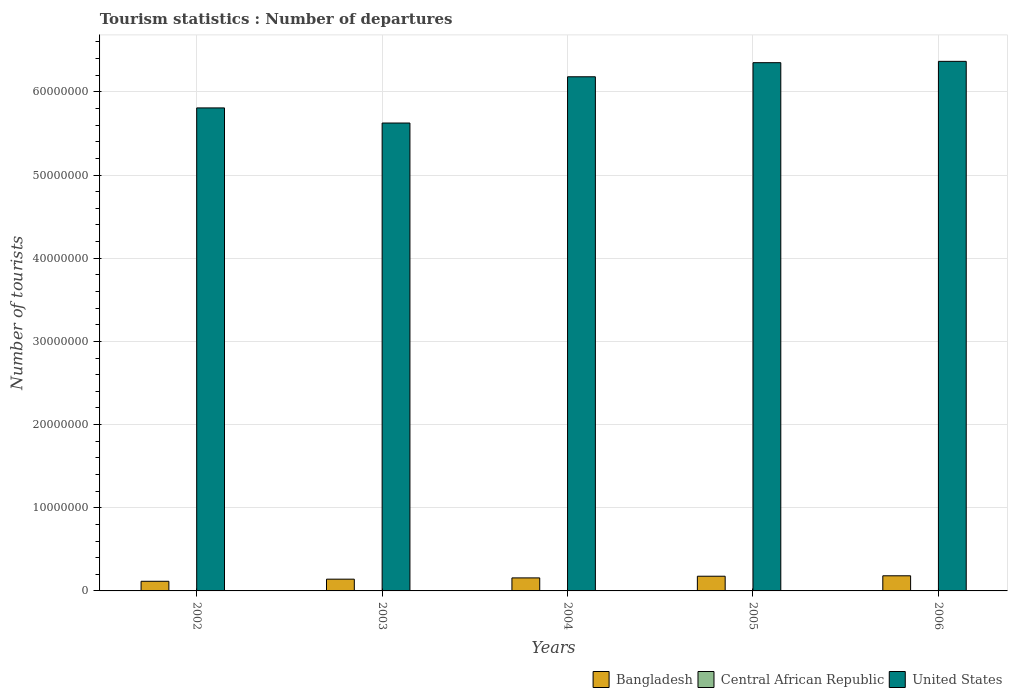How many groups of bars are there?
Provide a short and direct response. 5. Are the number of bars on each tick of the X-axis equal?
Keep it short and to the point. Yes. How many bars are there on the 3rd tick from the right?
Offer a very short reply. 3. What is the label of the 4th group of bars from the left?
Ensure brevity in your answer.  2005. In how many cases, is the number of bars for a given year not equal to the number of legend labels?
Your answer should be compact. 0. What is the number of tourist departures in Bangladesh in 2004?
Make the answer very short. 1.56e+06. Across all years, what is the maximum number of tourist departures in Bangladesh?
Make the answer very short. 1.82e+06. Across all years, what is the minimum number of tourist departures in Bangladesh?
Provide a succinct answer. 1.16e+06. In which year was the number of tourist departures in Bangladesh maximum?
Keep it short and to the point. 2006. In which year was the number of tourist departures in United States minimum?
Ensure brevity in your answer.  2003. What is the total number of tourist departures in Central African Republic in the graph?
Ensure brevity in your answer.  3.70e+04. What is the difference between the number of tourist departures in Central African Republic in 2002 and that in 2003?
Make the answer very short. -1000. What is the difference between the number of tourist departures in United States in 2005 and the number of tourist departures in Central African Republic in 2002?
Offer a very short reply. 6.35e+07. What is the average number of tourist departures in Central African Republic per year?
Make the answer very short. 7400. In the year 2002, what is the difference between the number of tourist departures in Bangladesh and number of tourist departures in United States?
Make the answer very short. -5.69e+07. What is the ratio of the number of tourist departures in Central African Republic in 2002 to that in 2004?
Provide a short and direct response. 0.71. Is the difference between the number of tourist departures in Bangladesh in 2003 and 2005 greater than the difference between the number of tourist departures in United States in 2003 and 2005?
Your answer should be compact. Yes. What is the difference between the highest and the second highest number of tourist departures in Central African Republic?
Offer a terse response. 3000. What is the difference between the highest and the lowest number of tourist departures in Bangladesh?
Make the answer very short. 6.61e+05. What does the 3rd bar from the left in 2004 represents?
Make the answer very short. United States. Is it the case that in every year, the sum of the number of tourist departures in Bangladesh and number of tourist departures in United States is greater than the number of tourist departures in Central African Republic?
Make the answer very short. Yes. How many bars are there?
Your answer should be very brief. 15. Are all the bars in the graph horizontal?
Your response must be concise. No. What is the difference between two consecutive major ticks on the Y-axis?
Give a very brief answer. 1.00e+07. Are the values on the major ticks of Y-axis written in scientific E-notation?
Provide a succinct answer. No. Does the graph contain any zero values?
Your response must be concise. No. Does the graph contain grids?
Your answer should be compact. Yes. What is the title of the graph?
Make the answer very short. Tourism statistics : Number of departures. What is the label or title of the X-axis?
Your answer should be very brief. Years. What is the label or title of the Y-axis?
Offer a terse response. Number of tourists. What is the Number of tourists in Bangladesh in 2002?
Your answer should be compact. 1.16e+06. What is the Number of tourists in United States in 2002?
Give a very brief answer. 5.81e+07. What is the Number of tourists of Bangladesh in 2003?
Keep it short and to the point. 1.41e+06. What is the Number of tourists of Central African Republic in 2003?
Your answer should be very brief. 6000. What is the Number of tourists of United States in 2003?
Make the answer very short. 5.62e+07. What is the Number of tourists in Bangladesh in 2004?
Keep it short and to the point. 1.56e+06. What is the Number of tourists of Central African Republic in 2004?
Your answer should be very brief. 7000. What is the Number of tourists in United States in 2004?
Your answer should be very brief. 6.18e+07. What is the Number of tourists in Bangladesh in 2005?
Make the answer very short. 1.77e+06. What is the Number of tourists of Central African Republic in 2005?
Make the answer very short. 8000. What is the Number of tourists of United States in 2005?
Provide a succinct answer. 6.35e+07. What is the Number of tourists in Bangladesh in 2006?
Your response must be concise. 1.82e+06. What is the Number of tourists in Central African Republic in 2006?
Make the answer very short. 1.10e+04. What is the Number of tourists in United States in 2006?
Offer a very short reply. 6.37e+07. Across all years, what is the maximum Number of tourists in Bangladesh?
Make the answer very short. 1.82e+06. Across all years, what is the maximum Number of tourists of Central African Republic?
Offer a very short reply. 1.10e+04. Across all years, what is the maximum Number of tourists in United States?
Provide a succinct answer. 6.37e+07. Across all years, what is the minimum Number of tourists in Bangladesh?
Offer a very short reply. 1.16e+06. Across all years, what is the minimum Number of tourists of Central African Republic?
Keep it short and to the point. 5000. Across all years, what is the minimum Number of tourists in United States?
Provide a succinct answer. 5.62e+07. What is the total Number of tourists in Bangladesh in the graph?
Keep it short and to the point. 7.72e+06. What is the total Number of tourists of Central African Republic in the graph?
Your answer should be compact. 3.70e+04. What is the total Number of tourists of United States in the graph?
Provide a succinct answer. 3.03e+08. What is the difference between the Number of tourists of Bangladesh in 2002 and that in 2003?
Provide a short and direct response. -2.56e+05. What is the difference between the Number of tourists of Central African Republic in 2002 and that in 2003?
Make the answer very short. -1000. What is the difference between the Number of tourists of United States in 2002 and that in 2003?
Your response must be concise. 1.82e+06. What is the difference between the Number of tourists in Bangladesh in 2002 and that in 2004?
Ensure brevity in your answer.  -4.07e+05. What is the difference between the Number of tourists in Central African Republic in 2002 and that in 2004?
Ensure brevity in your answer.  -2000. What is the difference between the Number of tourists of United States in 2002 and that in 2004?
Provide a succinct answer. -3.74e+06. What is the difference between the Number of tourists in Bangladesh in 2002 and that in 2005?
Make the answer very short. -6.09e+05. What is the difference between the Number of tourists in Central African Republic in 2002 and that in 2005?
Your answer should be compact. -3000. What is the difference between the Number of tourists in United States in 2002 and that in 2005?
Your response must be concise. -5.44e+06. What is the difference between the Number of tourists in Bangladesh in 2002 and that in 2006?
Your answer should be compact. -6.61e+05. What is the difference between the Number of tourists in Central African Republic in 2002 and that in 2006?
Your response must be concise. -6000. What is the difference between the Number of tourists in United States in 2002 and that in 2006?
Provide a succinct answer. -5.60e+06. What is the difference between the Number of tourists in Bangladesh in 2003 and that in 2004?
Your response must be concise. -1.51e+05. What is the difference between the Number of tourists of Central African Republic in 2003 and that in 2004?
Your answer should be compact. -1000. What is the difference between the Number of tourists of United States in 2003 and that in 2004?
Provide a short and direct response. -5.56e+06. What is the difference between the Number of tourists in Bangladesh in 2003 and that in 2005?
Your answer should be very brief. -3.53e+05. What is the difference between the Number of tourists in Central African Republic in 2003 and that in 2005?
Your answer should be compact. -2000. What is the difference between the Number of tourists of United States in 2003 and that in 2005?
Your answer should be compact. -7.25e+06. What is the difference between the Number of tourists in Bangladesh in 2003 and that in 2006?
Your response must be concise. -4.05e+05. What is the difference between the Number of tourists of Central African Republic in 2003 and that in 2006?
Make the answer very short. -5000. What is the difference between the Number of tourists in United States in 2003 and that in 2006?
Offer a terse response. -7.41e+06. What is the difference between the Number of tourists of Bangladesh in 2004 and that in 2005?
Ensure brevity in your answer.  -2.02e+05. What is the difference between the Number of tourists of Central African Republic in 2004 and that in 2005?
Ensure brevity in your answer.  -1000. What is the difference between the Number of tourists in United States in 2004 and that in 2005?
Provide a succinct answer. -1.69e+06. What is the difference between the Number of tourists in Bangladesh in 2004 and that in 2006?
Ensure brevity in your answer.  -2.54e+05. What is the difference between the Number of tourists in Central African Republic in 2004 and that in 2006?
Make the answer very short. -4000. What is the difference between the Number of tourists of United States in 2004 and that in 2006?
Give a very brief answer. -1.85e+06. What is the difference between the Number of tourists of Bangladesh in 2005 and that in 2006?
Ensure brevity in your answer.  -5.20e+04. What is the difference between the Number of tourists of Central African Republic in 2005 and that in 2006?
Your answer should be very brief. -3000. What is the difference between the Number of tourists in Bangladesh in 2002 and the Number of tourists in Central African Republic in 2003?
Give a very brief answer. 1.15e+06. What is the difference between the Number of tourists in Bangladesh in 2002 and the Number of tourists in United States in 2003?
Make the answer very short. -5.51e+07. What is the difference between the Number of tourists in Central African Republic in 2002 and the Number of tourists in United States in 2003?
Offer a terse response. -5.62e+07. What is the difference between the Number of tourists in Bangladesh in 2002 and the Number of tourists in Central African Republic in 2004?
Give a very brief answer. 1.15e+06. What is the difference between the Number of tourists in Bangladesh in 2002 and the Number of tourists in United States in 2004?
Provide a succinct answer. -6.07e+07. What is the difference between the Number of tourists in Central African Republic in 2002 and the Number of tourists in United States in 2004?
Give a very brief answer. -6.18e+07. What is the difference between the Number of tourists in Bangladesh in 2002 and the Number of tourists in Central African Republic in 2005?
Keep it short and to the point. 1.15e+06. What is the difference between the Number of tourists in Bangladesh in 2002 and the Number of tourists in United States in 2005?
Your answer should be compact. -6.23e+07. What is the difference between the Number of tourists of Central African Republic in 2002 and the Number of tourists of United States in 2005?
Make the answer very short. -6.35e+07. What is the difference between the Number of tourists of Bangladesh in 2002 and the Number of tourists of Central African Republic in 2006?
Your answer should be compact. 1.15e+06. What is the difference between the Number of tourists of Bangladesh in 2002 and the Number of tourists of United States in 2006?
Provide a short and direct response. -6.25e+07. What is the difference between the Number of tourists of Central African Republic in 2002 and the Number of tourists of United States in 2006?
Your answer should be very brief. -6.37e+07. What is the difference between the Number of tourists in Bangladesh in 2003 and the Number of tourists in Central African Republic in 2004?
Offer a very short reply. 1.41e+06. What is the difference between the Number of tourists of Bangladesh in 2003 and the Number of tourists of United States in 2004?
Provide a succinct answer. -6.04e+07. What is the difference between the Number of tourists of Central African Republic in 2003 and the Number of tourists of United States in 2004?
Your response must be concise. -6.18e+07. What is the difference between the Number of tourists in Bangladesh in 2003 and the Number of tourists in Central African Republic in 2005?
Provide a short and direct response. 1.41e+06. What is the difference between the Number of tourists in Bangladesh in 2003 and the Number of tourists in United States in 2005?
Make the answer very short. -6.21e+07. What is the difference between the Number of tourists of Central African Republic in 2003 and the Number of tourists of United States in 2005?
Offer a very short reply. -6.35e+07. What is the difference between the Number of tourists in Bangladesh in 2003 and the Number of tourists in Central African Republic in 2006?
Your answer should be compact. 1.40e+06. What is the difference between the Number of tourists of Bangladesh in 2003 and the Number of tourists of United States in 2006?
Your response must be concise. -6.22e+07. What is the difference between the Number of tourists of Central African Republic in 2003 and the Number of tourists of United States in 2006?
Offer a terse response. -6.37e+07. What is the difference between the Number of tourists in Bangladesh in 2004 and the Number of tourists in Central African Republic in 2005?
Provide a short and direct response. 1.56e+06. What is the difference between the Number of tourists in Bangladesh in 2004 and the Number of tourists in United States in 2005?
Your answer should be very brief. -6.19e+07. What is the difference between the Number of tourists of Central African Republic in 2004 and the Number of tourists of United States in 2005?
Provide a short and direct response. -6.35e+07. What is the difference between the Number of tourists in Bangladesh in 2004 and the Number of tourists in Central African Republic in 2006?
Make the answer very short. 1.55e+06. What is the difference between the Number of tourists of Bangladesh in 2004 and the Number of tourists of United States in 2006?
Provide a short and direct response. -6.21e+07. What is the difference between the Number of tourists in Central African Republic in 2004 and the Number of tourists in United States in 2006?
Make the answer very short. -6.37e+07. What is the difference between the Number of tourists of Bangladesh in 2005 and the Number of tourists of Central African Republic in 2006?
Provide a succinct answer. 1.76e+06. What is the difference between the Number of tourists in Bangladesh in 2005 and the Number of tourists in United States in 2006?
Provide a succinct answer. -6.19e+07. What is the difference between the Number of tourists of Central African Republic in 2005 and the Number of tourists of United States in 2006?
Give a very brief answer. -6.37e+07. What is the average Number of tourists in Bangladesh per year?
Keep it short and to the point. 1.54e+06. What is the average Number of tourists in Central African Republic per year?
Provide a succinct answer. 7400. What is the average Number of tourists in United States per year?
Offer a terse response. 6.07e+07. In the year 2002, what is the difference between the Number of tourists of Bangladesh and Number of tourists of Central African Republic?
Your answer should be compact. 1.15e+06. In the year 2002, what is the difference between the Number of tourists in Bangladesh and Number of tourists in United States?
Make the answer very short. -5.69e+07. In the year 2002, what is the difference between the Number of tourists in Central African Republic and Number of tourists in United States?
Give a very brief answer. -5.81e+07. In the year 2003, what is the difference between the Number of tourists in Bangladesh and Number of tourists in Central African Republic?
Give a very brief answer. 1.41e+06. In the year 2003, what is the difference between the Number of tourists in Bangladesh and Number of tourists in United States?
Offer a very short reply. -5.48e+07. In the year 2003, what is the difference between the Number of tourists of Central African Republic and Number of tourists of United States?
Keep it short and to the point. -5.62e+07. In the year 2004, what is the difference between the Number of tourists in Bangladesh and Number of tourists in Central African Republic?
Your answer should be compact. 1.56e+06. In the year 2004, what is the difference between the Number of tourists in Bangladesh and Number of tourists in United States?
Provide a short and direct response. -6.02e+07. In the year 2004, what is the difference between the Number of tourists in Central African Republic and Number of tourists in United States?
Keep it short and to the point. -6.18e+07. In the year 2005, what is the difference between the Number of tourists in Bangladesh and Number of tourists in Central African Republic?
Your response must be concise. 1.76e+06. In the year 2005, what is the difference between the Number of tourists of Bangladesh and Number of tourists of United States?
Keep it short and to the point. -6.17e+07. In the year 2005, what is the difference between the Number of tourists of Central African Republic and Number of tourists of United States?
Provide a succinct answer. -6.35e+07. In the year 2006, what is the difference between the Number of tourists in Bangladesh and Number of tourists in Central African Republic?
Provide a short and direct response. 1.81e+06. In the year 2006, what is the difference between the Number of tourists in Bangladesh and Number of tourists in United States?
Your answer should be very brief. -6.18e+07. In the year 2006, what is the difference between the Number of tourists in Central African Republic and Number of tourists in United States?
Provide a succinct answer. -6.37e+07. What is the ratio of the Number of tourists of Bangladesh in 2002 to that in 2003?
Offer a terse response. 0.82. What is the ratio of the Number of tourists in United States in 2002 to that in 2003?
Give a very brief answer. 1.03. What is the ratio of the Number of tourists of Bangladesh in 2002 to that in 2004?
Provide a short and direct response. 0.74. What is the ratio of the Number of tourists in United States in 2002 to that in 2004?
Your answer should be very brief. 0.94. What is the ratio of the Number of tourists of Bangladesh in 2002 to that in 2005?
Provide a succinct answer. 0.66. What is the ratio of the Number of tourists of United States in 2002 to that in 2005?
Ensure brevity in your answer.  0.91. What is the ratio of the Number of tourists of Bangladesh in 2002 to that in 2006?
Provide a short and direct response. 0.64. What is the ratio of the Number of tourists in Central African Republic in 2002 to that in 2006?
Keep it short and to the point. 0.45. What is the ratio of the Number of tourists in United States in 2002 to that in 2006?
Offer a very short reply. 0.91. What is the ratio of the Number of tourists in Bangladesh in 2003 to that in 2004?
Offer a terse response. 0.9. What is the ratio of the Number of tourists of United States in 2003 to that in 2004?
Offer a very short reply. 0.91. What is the ratio of the Number of tourists in Bangladesh in 2003 to that in 2005?
Your answer should be very brief. 0.8. What is the ratio of the Number of tourists in Central African Republic in 2003 to that in 2005?
Provide a short and direct response. 0.75. What is the ratio of the Number of tourists in United States in 2003 to that in 2005?
Your answer should be compact. 0.89. What is the ratio of the Number of tourists in Bangladesh in 2003 to that in 2006?
Provide a short and direct response. 0.78. What is the ratio of the Number of tourists in Central African Republic in 2003 to that in 2006?
Keep it short and to the point. 0.55. What is the ratio of the Number of tourists in United States in 2003 to that in 2006?
Your answer should be compact. 0.88. What is the ratio of the Number of tourists in Bangladesh in 2004 to that in 2005?
Provide a short and direct response. 0.89. What is the ratio of the Number of tourists of Central African Republic in 2004 to that in 2005?
Your response must be concise. 0.88. What is the ratio of the Number of tourists in United States in 2004 to that in 2005?
Provide a succinct answer. 0.97. What is the ratio of the Number of tourists of Bangladesh in 2004 to that in 2006?
Make the answer very short. 0.86. What is the ratio of the Number of tourists of Central African Republic in 2004 to that in 2006?
Your answer should be very brief. 0.64. What is the ratio of the Number of tourists in United States in 2004 to that in 2006?
Provide a short and direct response. 0.97. What is the ratio of the Number of tourists in Bangladesh in 2005 to that in 2006?
Your answer should be very brief. 0.97. What is the ratio of the Number of tourists of Central African Republic in 2005 to that in 2006?
Keep it short and to the point. 0.73. What is the difference between the highest and the second highest Number of tourists in Bangladesh?
Your answer should be compact. 5.20e+04. What is the difference between the highest and the second highest Number of tourists of Central African Republic?
Give a very brief answer. 3000. What is the difference between the highest and the lowest Number of tourists of Bangladesh?
Ensure brevity in your answer.  6.61e+05. What is the difference between the highest and the lowest Number of tourists in Central African Republic?
Your answer should be compact. 6000. What is the difference between the highest and the lowest Number of tourists in United States?
Your answer should be very brief. 7.41e+06. 